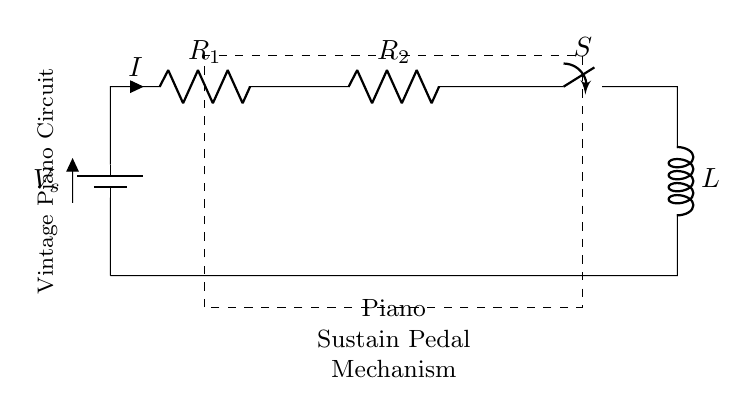What is the type of battery in this circuit? The circuit shows a battery component labeled as 'V_s'. This indicates that the battery is the source of voltage for the circuit.
Answer: battery What are the resistances present in the circuit? There are two resistors in the circuit, labeled as 'R_1' and 'R_2'. The presence of two resistors means the circuit includes resistance that impacts current flow.
Answer: R_1 and R_2 What is the function of switch 'S' in this circuit? The switch 'S' is designed to open or close the circuit. When closed, the circuit allows current to flow; when open, the circuit interrupts current flow, serving as a control mechanism.
Answer: control What is the total resistance of this circuit when switch 'S' is closed? In a series circuit, the total resistance is the sum of the individual resistances. Thus, the total resistance equals R_1 plus R_2 when the switch is closed.
Answer: R_1 + R_2 What happens to current 'I' if one of the resistors is increased in value? According to Ohm's Law, if resistance increases while the voltage remains constant, the current will decrease. This is evident as the entire series circuit's behavior is dictated by total resistance.
Answer: decreases Is this circuit a parallel or series circuit? The components in the circuit are arranged in a single path for the current to flow, hence the circuit is classified as a series circuit.
Answer: series 